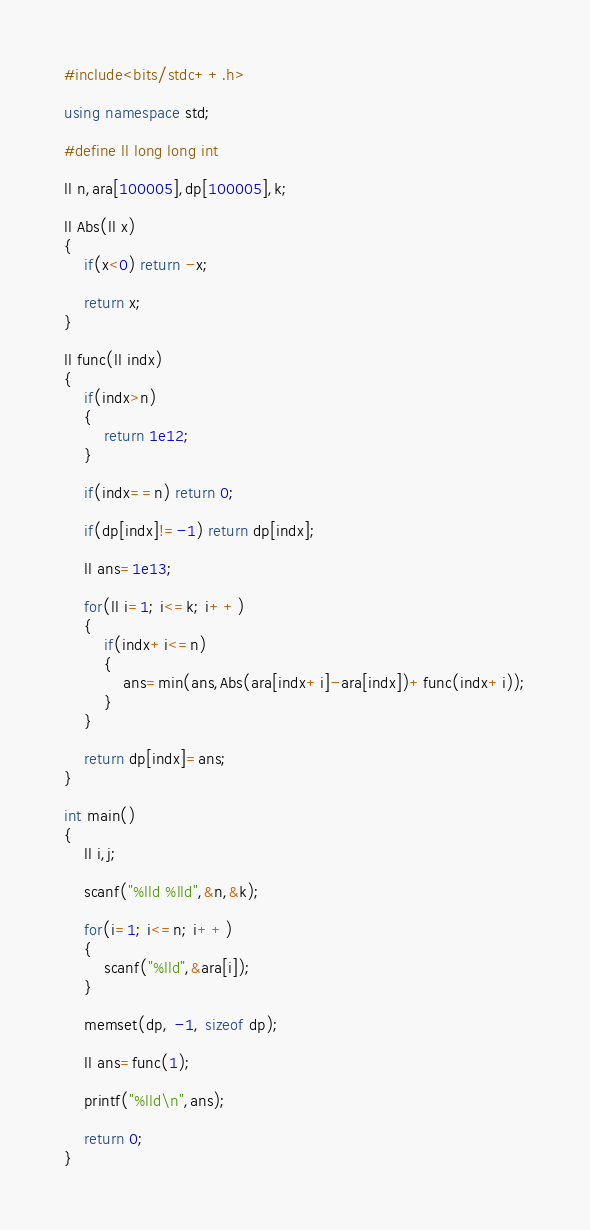Convert code to text. <code><loc_0><loc_0><loc_500><loc_500><_C++_>#include<bits/stdc++.h>

using namespace std;

#define ll long long int

ll n,ara[100005],dp[100005],k;

ll Abs(ll x)
{
    if(x<0) return -x;

    return x;
}

ll func(ll indx)
{
    if(indx>n)
    {
        return 1e12;
    }

    if(indx==n) return 0;

    if(dp[indx]!=-1) return dp[indx];

    ll ans=1e13;

    for(ll i=1; i<=k; i++)
    {
        if(indx+i<=n)
        {
            ans=min(ans,Abs(ara[indx+i]-ara[indx])+func(indx+i));
        }
    }

    return dp[indx]=ans;
}

int main()
{
    ll i,j;

    scanf("%lld %lld",&n,&k);

    for(i=1; i<=n; i++)
    {
        scanf("%lld",&ara[i]);
    }

    memset(dp, -1, sizeof dp);

    ll ans=func(1);

    printf("%lld\n",ans);

    return 0;
}
</code> 